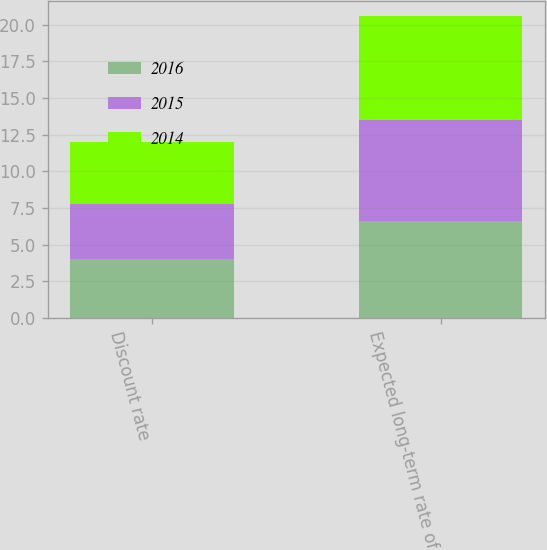Convert chart to OTSL. <chart><loc_0><loc_0><loc_500><loc_500><stacked_bar_chart><ecel><fcel>Discount rate<fcel>Expected long-term rate of<nl><fcel>2016<fcel>4<fcel>6.6<nl><fcel>2015<fcel>3.75<fcel>6.9<nl><fcel>2014<fcel>4.25<fcel>7.1<nl></chart> 